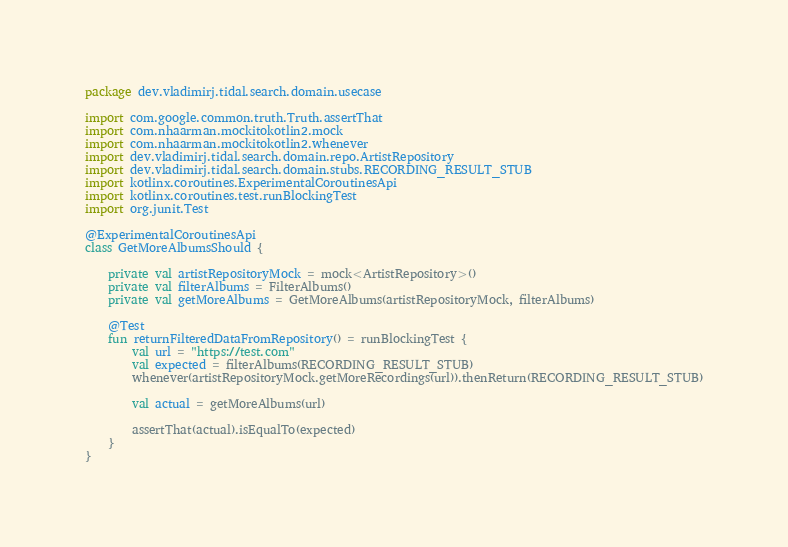Convert code to text. <code><loc_0><loc_0><loc_500><loc_500><_Kotlin_>package dev.vladimirj.tidal.search.domain.usecase

import com.google.common.truth.Truth.assertThat
import com.nhaarman.mockitokotlin2.mock
import com.nhaarman.mockitokotlin2.whenever
import dev.vladimirj.tidal.search.domain.repo.ArtistRepository
import dev.vladimirj.tidal.search.domain.stubs.RECORDING_RESULT_STUB
import kotlinx.coroutines.ExperimentalCoroutinesApi
import kotlinx.coroutines.test.runBlockingTest
import org.junit.Test

@ExperimentalCoroutinesApi
class GetMoreAlbumsShould {

    private val artistRepositoryMock = mock<ArtistRepository>()
    private val filterAlbums = FilterAlbums()
    private val getMoreAlbums = GetMoreAlbums(artistRepositoryMock, filterAlbums)

    @Test
    fun returnFilteredDataFromRepository() = runBlockingTest {
        val url = "https://test.com"
        val expected = filterAlbums(RECORDING_RESULT_STUB)
        whenever(artistRepositoryMock.getMoreRecordings(url)).thenReturn(RECORDING_RESULT_STUB)

        val actual = getMoreAlbums(url)

        assertThat(actual).isEqualTo(expected)
    }
}</code> 